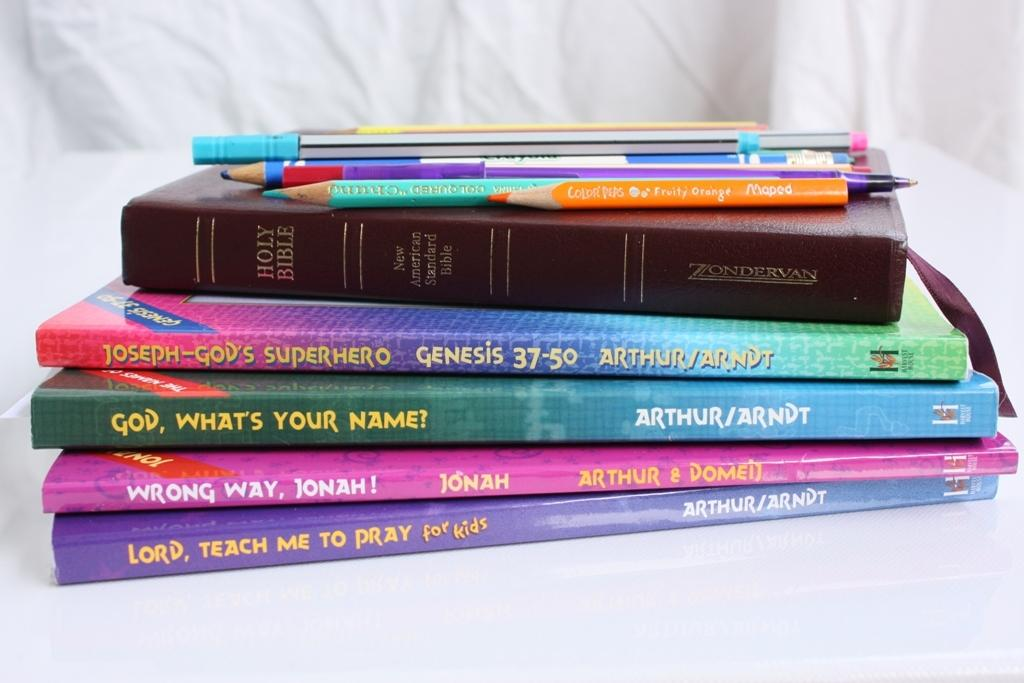<image>
Relay a brief, clear account of the picture shown. Several religious books having to do with God stacked on top of each other. 